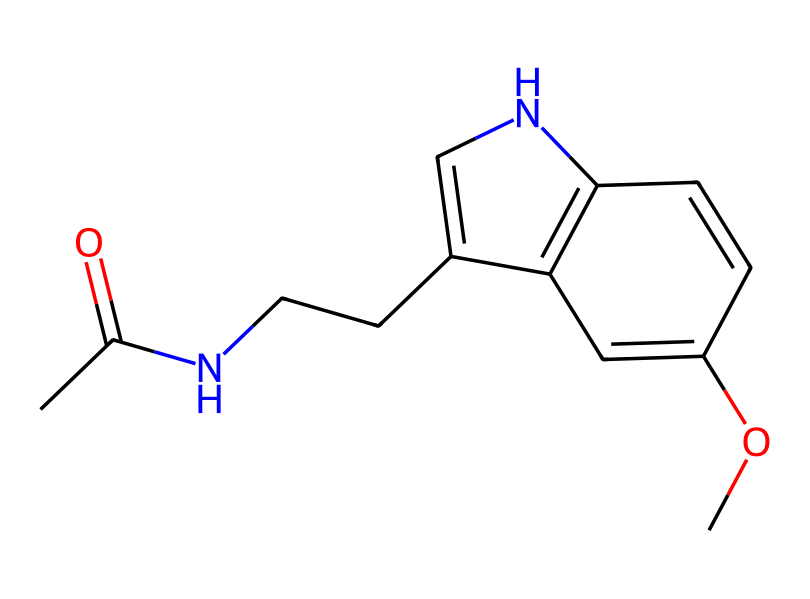What is the molecular formula of melatonin? To determine the molecular formula, count the atoms of each element represented in the SMILES. The breakdown is as follows: 10 Carbon (C), 13 Hydrogen (H), 1 Nitrogen (N), and 1 Oxygen (O). This leads to the molecular formula being C13H16N2O2.
Answer: C13H16N2O2 How many nitrogen atoms are present in melatonin? By analyzing the SMILES representation, we can count the distinct nitrogen atoms in the chemical structure. There are 2 nitrogen atoms indicated in the SMILES.
Answer: 2 What kind of functional groups are present in melatonin? Looking at the structure, we see an amide group (due to the presence of nitrogen bonded to a carbonyl) and an ether group (due to the presence of an oxygen connected to two carbons). These are the primary functional groups in melatonin.
Answer: amide and ether What is the role of melatonin in the human body? Melatonin's primary role in the human body is to regulate sleep-wake cycles (circadian rhythms). It is produced in response to darkness, signaling the body to prepare for sleep.
Answer: sleep regulation What type of compound is melatonin classified as? Given its structure and function, melatonin is classified as a hormone since it is produced by the pineal gland and functions to communicate signals throughout the body related to sleep.
Answer: hormone What structural feature indicates that melatonin is derived from tryptophan? The presence of the indole ring structure, which is a characteristic feature of tryptophan, indicates that melatonin is derived from this amino acid. This ring is crucial for its biological activities.
Answer: indole ring How many rings are present in the melatonin structure? Analyzing the SMILES reveals two fused rings: one is the indole structure, and the other is a substituted benzene ring. This total yields a count of two rings in its structure.
Answer: 2 